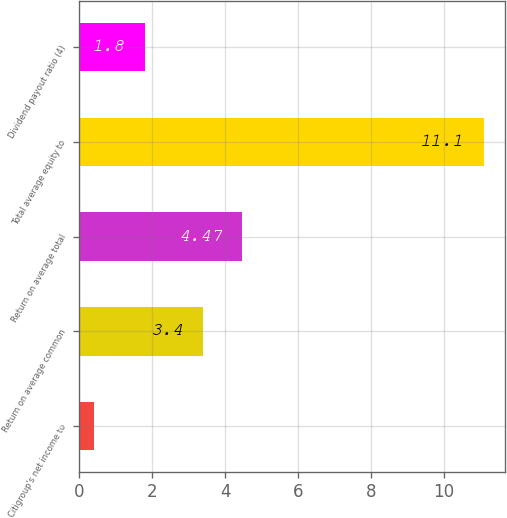Convert chart to OTSL. <chart><loc_0><loc_0><loc_500><loc_500><bar_chart><fcel>Citigroup's net income to<fcel>Return on average common<fcel>Return on average total<fcel>Total average equity to<fcel>Dividend payout ratio (4)<nl><fcel>0.39<fcel>3.4<fcel>4.47<fcel>11.1<fcel>1.8<nl></chart> 